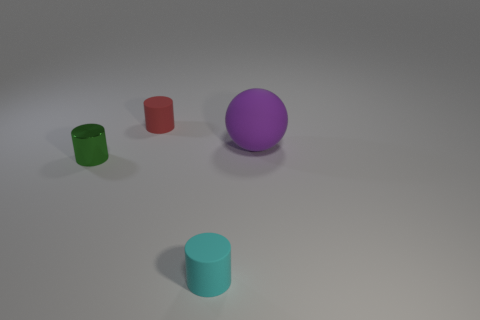Add 1 small purple shiny objects. How many objects exist? 5 Subtract all balls. How many objects are left? 3 Subtract all tiny matte objects. Subtract all red cylinders. How many objects are left? 1 Add 4 cyan matte objects. How many cyan matte objects are left? 5 Add 2 big things. How many big things exist? 3 Subtract 0 green blocks. How many objects are left? 4 